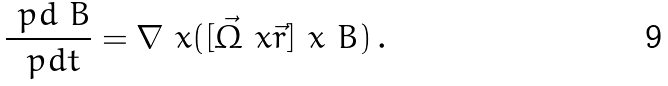<formula> <loc_0><loc_0><loc_500><loc_500>\frac { \ p d \ B } { \ p d t } = \nabla \ x ( [ \vec { \Omega } \ x \vec { r } ] \ x \ B ) \, .</formula> 